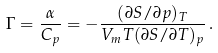<formula> <loc_0><loc_0><loc_500><loc_500>\Gamma = \frac { \alpha } { C _ { p } } = - \frac { ( \partial S / \partial p ) _ { T } } { V _ { m } T ( \partial S / \partial T ) _ { p } } \, .</formula> 